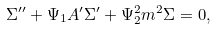Convert formula to latex. <formula><loc_0><loc_0><loc_500><loc_500>\Sigma ^ { \prime \prime } + \Psi _ { 1 } A ^ { \prime } \Sigma ^ { \prime } + \Psi _ { 2 } ^ { 2 } m ^ { 2 } \Sigma = 0 ,</formula> 